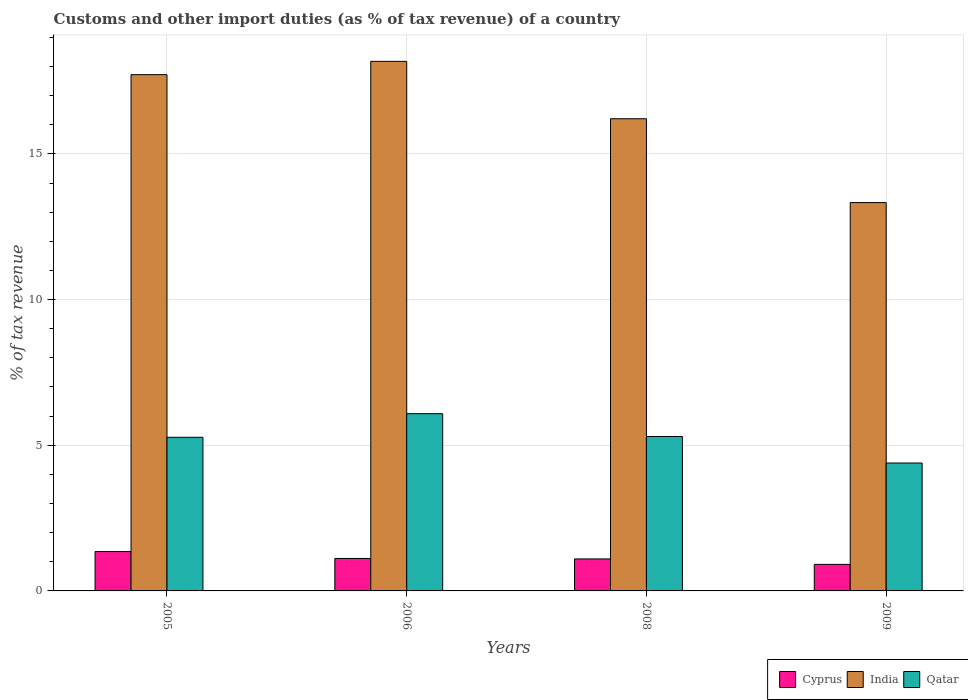How many groups of bars are there?
Provide a succinct answer. 4. Are the number of bars per tick equal to the number of legend labels?
Your answer should be very brief. Yes. What is the label of the 3rd group of bars from the left?
Offer a very short reply. 2008. What is the percentage of tax revenue from customs in Cyprus in 2005?
Your answer should be compact. 1.35. Across all years, what is the maximum percentage of tax revenue from customs in Cyprus?
Offer a terse response. 1.35. Across all years, what is the minimum percentage of tax revenue from customs in Cyprus?
Provide a succinct answer. 0.91. In which year was the percentage of tax revenue from customs in Cyprus minimum?
Your answer should be very brief. 2009. What is the total percentage of tax revenue from customs in India in the graph?
Provide a short and direct response. 65.43. What is the difference between the percentage of tax revenue from customs in Qatar in 2008 and that in 2009?
Your answer should be compact. 0.91. What is the difference between the percentage of tax revenue from customs in Qatar in 2008 and the percentage of tax revenue from customs in India in 2009?
Provide a short and direct response. -8.03. What is the average percentage of tax revenue from customs in Cyprus per year?
Offer a terse response. 1.12. In the year 2009, what is the difference between the percentage of tax revenue from customs in India and percentage of tax revenue from customs in Qatar?
Give a very brief answer. 8.94. What is the ratio of the percentage of tax revenue from customs in Qatar in 2006 to that in 2009?
Keep it short and to the point. 1.39. Is the percentage of tax revenue from customs in Cyprus in 2006 less than that in 2009?
Your response must be concise. No. What is the difference between the highest and the second highest percentage of tax revenue from customs in Qatar?
Provide a succinct answer. 0.78. What is the difference between the highest and the lowest percentage of tax revenue from customs in Qatar?
Offer a terse response. 1.69. Is the sum of the percentage of tax revenue from customs in Qatar in 2006 and 2008 greater than the maximum percentage of tax revenue from customs in India across all years?
Make the answer very short. No. How many bars are there?
Your answer should be compact. 12. Are all the bars in the graph horizontal?
Your answer should be very brief. No. How many years are there in the graph?
Offer a very short reply. 4. Does the graph contain grids?
Your answer should be compact. Yes. How are the legend labels stacked?
Give a very brief answer. Horizontal. What is the title of the graph?
Your response must be concise. Customs and other import duties (as % of tax revenue) of a country. What is the label or title of the X-axis?
Keep it short and to the point. Years. What is the label or title of the Y-axis?
Provide a succinct answer. % of tax revenue. What is the % of tax revenue in Cyprus in 2005?
Your answer should be compact. 1.35. What is the % of tax revenue in India in 2005?
Offer a very short reply. 17.72. What is the % of tax revenue in Qatar in 2005?
Make the answer very short. 5.27. What is the % of tax revenue in Cyprus in 2006?
Offer a terse response. 1.11. What is the % of tax revenue in India in 2006?
Your response must be concise. 18.18. What is the % of tax revenue in Qatar in 2006?
Provide a succinct answer. 6.08. What is the % of tax revenue in Cyprus in 2008?
Offer a very short reply. 1.1. What is the % of tax revenue of India in 2008?
Provide a short and direct response. 16.21. What is the % of tax revenue in Qatar in 2008?
Provide a short and direct response. 5.3. What is the % of tax revenue in Cyprus in 2009?
Your response must be concise. 0.91. What is the % of tax revenue in India in 2009?
Give a very brief answer. 13.33. What is the % of tax revenue of Qatar in 2009?
Ensure brevity in your answer.  4.39. Across all years, what is the maximum % of tax revenue of Cyprus?
Keep it short and to the point. 1.35. Across all years, what is the maximum % of tax revenue in India?
Offer a very short reply. 18.18. Across all years, what is the maximum % of tax revenue of Qatar?
Offer a very short reply. 6.08. Across all years, what is the minimum % of tax revenue in Cyprus?
Ensure brevity in your answer.  0.91. Across all years, what is the minimum % of tax revenue in India?
Provide a short and direct response. 13.33. Across all years, what is the minimum % of tax revenue of Qatar?
Your response must be concise. 4.39. What is the total % of tax revenue in Cyprus in the graph?
Offer a very short reply. 4.48. What is the total % of tax revenue of India in the graph?
Your answer should be compact. 65.43. What is the total % of tax revenue of Qatar in the graph?
Offer a terse response. 21.05. What is the difference between the % of tax revenue in Cyprus in 2005 and that in 2006?
Keep it short and to the point. 0.24. What is the difference between the % of tax revenue in India in 2005 and that in 2006?
Give a very brief answer. -0.46. What is the difference between the % of tax revenue in Qatar in 2005 and that in 2006?
Ensure brevity in your answer.  -0.81. What is the difference between the % of tax revenue of Cyprus in 2005 and that in 2008?
Keep it short and to the point. 0.25. What is the difference between the % of tax revenue of India in 2005 and that in 2008?
Offer a terse response. 1.51. What is the difference between the % of tax revenue in Qatar in 2005 and that in 2008?
Provide a succinct answer. -0.03. What is the difference between the % of tax revenue in Cyprus in 2005 and that in 2009?
Keep it short and to the point. 0.44. What is the difference between the % of tax revenue of India in 2005 and that in 2009?
Your response must be concise. 4.39. What is the difference between the % of tax revenue in Qatar in 2005 and that in 2009?
Your response must be concise. 0.88. What is the difference between the % of tax revenue in Cyprus in 2006 and that in 2008?
Your answer should be very brief. 0.02. What is the difference between the % of tax revenue of India in 2006 and that in 2008?
Provide a short and direct response. 1.97. What is the difference between the % of tax revenue in Qatar in 2006 and that in 2008?
Your answer should be very brief. 0.78. What is the difference between the % of tax revenue of Cyprus in 2006 and that in 2009?
Provide a succinct answer. 0.2. What is the difference between the % of tax revenue of India in 2006 and that in 2009?
Keep it short and to the point. 4.85. What is the difference between the % of tax revenue of Qatar in 2006 and that in 2009?
Make the answer very short. 1.69. What is the difference between the % of tax revenue in Cyprus in 2008 and that in 2009?
Your answer should be very brief. 0.19. What is the difference between the % of tax revenue of India in 2008 and that in 2009?
Offer a very short reply. 2.88. What is the difference between the % of tax revenue of Qatar in 2008 and that in 2009?
Offer a terse response. 0.91. What is the difference between the % of tax revenue in Cyprus in 2005 and the % of tax revenue in India in 2006?
Keep it short and to the point. -16.82. What is the difference between the % of tax revenue of Cyprus in 2005 and the % of tax revenue of Qatar in 2006?
Ensure brevity in your answer.  -4.73. What is the difference between the % of tax revenue of India in 2005 and the % of tax revenue of Qatar in 2006?
Your answer should be very brief. 11.64. What is the difference between the % of tax revenue of Cyprus in 2005 and the % of tax revenue of India in 2008?
Your answer should be compact. -14.85. What is the difference between the % of tax revenue in Cyprus in 2005 and the % of tax revenue in Qatar in 2008?
Your answer should be very brief. -3.95. What is the difference between the % of tax revenue in India in 2005 and the % of tax revenue in Qatar in 2008?
Make the answer very short. 12.42. What is the difference between the % of tax revenue of Cyprus in 2005 and the % of tax revenue of India in 2009?
Offer a terse response. -11.98. What is the difference between the % of tax revenue in Cyprus in 2005 and the % of tax revenue in Qatar in 2009?
Provide a succinct answer. -3.04. What is the difference between the % of tax revenue of India in 2005 and the % of tax revenue of Qatar in 2009?
Keep it short and to the point. 13.33. What is the difference between the % of tax revenue of Cyprus in 2006 and the % of tax revenue of India in 2008?
Your answer should be very brief. -15.09. What is the difference between the % of tax revenue in Cyprus in 2006 and the % of tax revenue in Qatar in 2008?
Your answer should be compact. -4.19. What is the difference between the % of tax revenue of India in 2006 and the % of tax revenue of Qatar in 2008?
Your answer should be compact. 12.88. What is the difference between the % of tax revenue of Cyprus in 2006 and the % of tax revenue of India in 2009?
Your answer should be very brief. -12.21. What is the difference between the % of tax revenue in Cyprus in 2006 and the % of tax revenue in Qatar in 2009?
Offer a terse response. -3.28. What is the difference between the % of tax revenue of India in 2006 and the % of tax revenue of Qatar in 2009?
Keep it short and to the point. 13.79. What is the difference between the % of tax revenue of Cyprus in 2008 and the % of tax revenue of India in 2009?
Offer a terse response. -12.23. What is the difference between the % of tax revenue in Cyprus in 2008 and the % of tax revenue in Qatar in 2009?
Keep it short and to the point. -3.29. What is the difference between the % of tax revenue in India in 2008 and the % of tax revenue in Qatar in 2009?
Your answer should be very brief. 11.82. What is the average % of tax revenue of Cyprus per year?
Your response must be concise. 1.12. What is the average % of tax revenue in India per year?
Ensure brevity in your answer.  16.36. What is the average % of tax revenue of Qatar per year?
Provide a succinct answer. 5.26. In the year 2005, what is the difference between the % of tax revenue in Cyprus and % of tax revenue in India?
Give a very brief answer. -16.37. In the year 2005, what is the difference between the % of tax revenue in Cyprus and % of tax revenue in Qatar?
Your answer should be very brief. -3.92. In the year 2005, what is the difference between the % of tax revenue of India and % of tax revenue of Qatar?
Provide a short and direct response. 12.45. In the year 2006, what is the difference between the % of tax revenue in Cyprus and % of tax revenue in India?
Provide a short and direct response. -17.06. In the year 2006, what is the difference between the % of tax revenue in Cyprus and % of tax revenue in Qatar?
Provide a succinct answer. -4.97. In the year 2006, what is the difference between the % of tax revenue in India and % of tax revenue in Qatar?
Offer a very short reply. 12.09. In the year 2008, what is the difference between the % of tax revenue of Cyprus and % of tax revenue of India?
Provide a short and direct response. -15.11. In the year 2008, what is the difference between the % of tax revenue of Cyprus and % of tax revenue of Qatar?
Ensure brevity in your answer.  -4.2. In the year 2008, what is the difference between the % of tax revenue of India and % of tax revenue of Qatar?
Your response must be concise. 10.91. In the year 2009, what is the difference between the % of tax revenue of Cyprus and % of tax revenue of India?
Offer a terse response. -12.42. In the year 2009, what is the difference between the % of tax revenue of Cyprus and % of tax revenue of Qatar?
Your answer should be very brief. -3.48. In the year 2009, what is the difference between the % of tax revenue of India and % of tax revenue of Qatar?
Keep it short and to the point. 8.94. What is the ratio of the % of tax revenue in Cyprus in 2005 to that in 2006?
Make the answer very short. 1.21. What is the ratio of the % of tax revenue in India in 2005 to that in 2006?
Your answer should be compact. 0.97. What is the ratio of the % of tax revenue of Qatar in 2005 to that in 2006?
Offer a very short reply. 0.87. What is the ratio of the % of tax revenue in Cyprus in 2005 to that in 2008?
Provide a succinct answer. 1.23. What is the ratio of the % of tax revenue in India in 2005 to that in 2008?
Give a very brief answer. 1.09. What is the ratio of the % of tax revenue of Cyprus in 2005 to that in 2009?
Give a very brief answer. 1.48. What is the ratio of the % of tax revenue in India in 2005 to that in 2009?
Your response must be concise. 1.33. What is the ratio of the % of tax revenue in Qatar in 2005 to that in 2009?
Your answer should be compact. 1.2. What is the ratio of the % of tax revenue in Cyprus in 2006 to that in 2008?
Give a very brief answer. 1.01. What is the ratio of the % of tax revenue in India in 2006 to that in 2008?
Give a very brief answer. 1.12. What is the ratio of the % of tax revenue in Qatar in 2006 to that in 2008?
Provide a succinct answer. 1.15. What is the ratio of the % of tax revenue of Cyprus in 2006 to that in 2009?
Your answer should be compact. 1.22. What is the ratio of the % of tax revenue of India in 2006 to that in 2009?
Provide a short and direct response. 1.36. What is the ratio of the % of tax revenue of Qatar in 2006 to that in 2009?
Your response must be concise. 1.39. What is the ratio of the % of tax revenue of Cyprus in 2008 to that in 2009?
Make the answer very short. 1.21. What is the ratio of the % of tax revenue in India in 2008 to that in 2009?
Ensure brevity in your answer.  1.22. What is the ratio of the % of tax revenue of Qatar in 2008 to that in 2009?
Provide a succinct answer. 1.21. What is the difference between the highest and the second highest % of tax revenue of Cyprus?
Provide a short and direct response. 0.24. What is the difference between the highest and the second highest % of tax revenue in India?
Offer a very short reply. 0.46. What is the difference between the highest and the second highest % of tax revenue in Qatar?
Offer a very short reply. 0.78. What is the difference between the highest and the lowest % of tax revenue in Cyprus?
Give a very brief answer. 0.44. What is the difference between the highest and the lowest % of tax revenue of India?
Provide a succinct answer. 4.85. What is the difference between the highest and the lowest % of tax revenue of Qatar?
Offer a terse response. 1.69. 